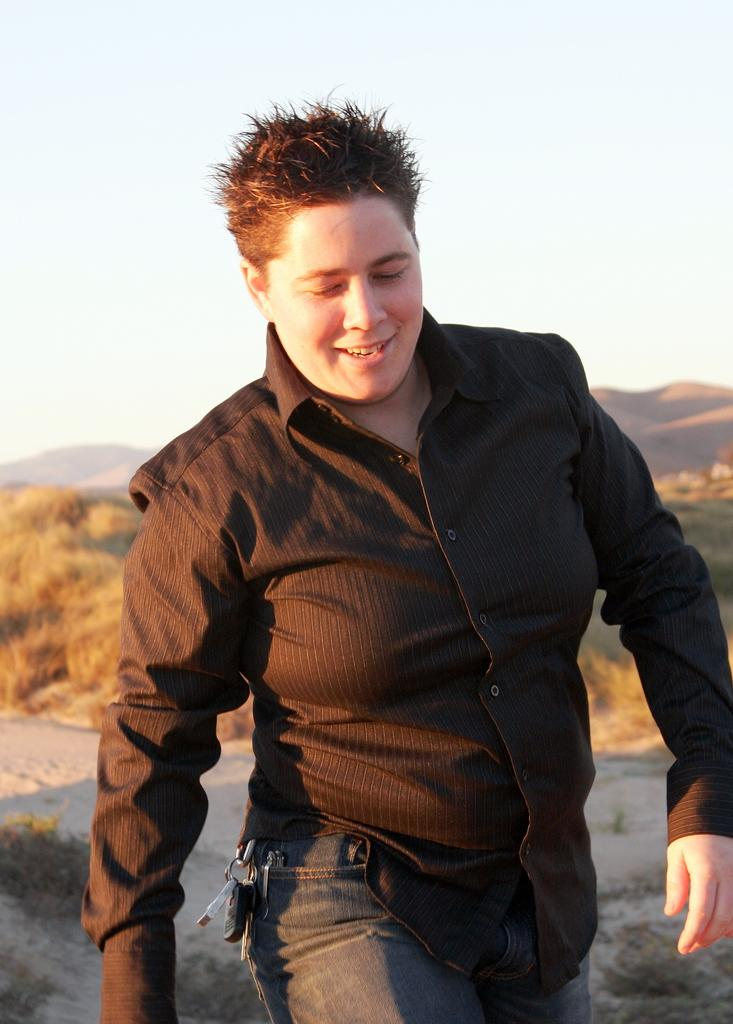Who is present in the image? There is a man in the image. What can be seen in the background of the image? There are trees, hills, and the sky visible in the background of the image. What type of food is the man holding in the image? There is no food visible in the image, and the man is not holding anything. 